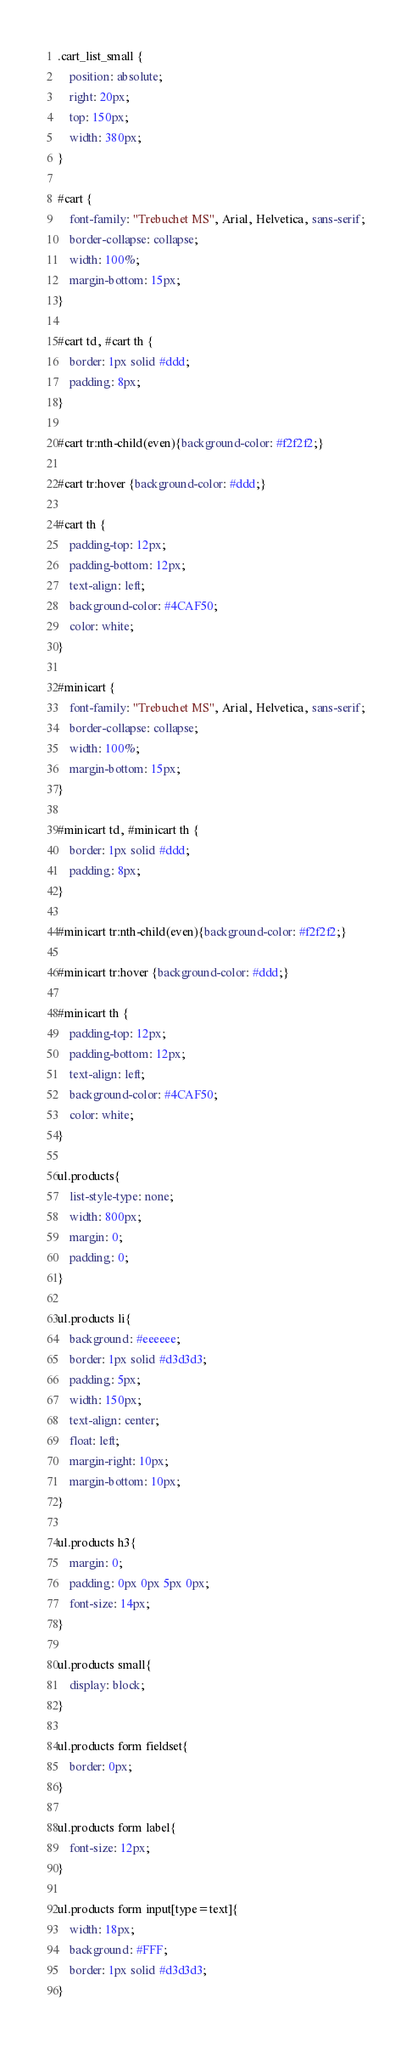Convert code to text. <code><loc_0><loc_0><loc_500><loc_500><_CSS_>.cart_list_small {
    position: absolute;
    right: 20px;
    top: 150px;
    width: 380px;
}

#cart {
    font-family: "Trebuchet MS", Arial, Helvetica, sans-serif;
    border-collapse: collapse;
    width: 100%;
    margin-bottom: 15px;
}

#cart td, #cart th {
    border: 1px solid #ddd;
    padding: 8px;
}

#cart tr:nth-child(even){background-color: #f2f2f2;}

#cart tr:hover {background-color: #ddd;}

#cart th {
    padding-top: 12px;
    padding-bottom: 12px;
    text-align: left;
    background-color: #4CAF50;
    color: white;
}

#minicart {
    font-family: "Trebuchet MS", Arial, Helvetica, sans-serif;
    border-collapse: collapse;
    width: 100%;
    margin-bottom: 15px;
}

#minicart td, #minicart th {
    border: 1px solid #ddd;
    padding: 8px;
}

#minicart tr:nth-child(even){background-color: #f2f2f2;}

#minicart tr:hover {background-color: #ddd;}

#minicart th {
    padding-top: 12px;
    padding-bottom: 12px;
    text-align: left;
    background-color: #4CAF50;
    color: white;
}

ul.products{
    list-style-type: none;
    width: 800px;
    margin: 0;
    padding: 0;
}

ul.products li{
    background: #eeeeee;
    border: 1px solid #d3d3d3;
    padding: 5px;
    width: 150px;
    text-align: center;
    float: left;
    margin-right: 10px;
    margin-bottom: 10px;
}

ul.products h3{
    margin: 0;
    padding: 0px 0px 5px 0px;
    font-size: 14px;
}
 
ul.products small{
    display: block;
}
 
ul.products form fieldset{
    border: 0px;
}
 
ul.products form label{
    font-size: 12px;
}
 
ul.products form input[type=text]{
    width: 18px;
    background: #FFF;
    border: 1px solid #d3d3d3;
}</code> 